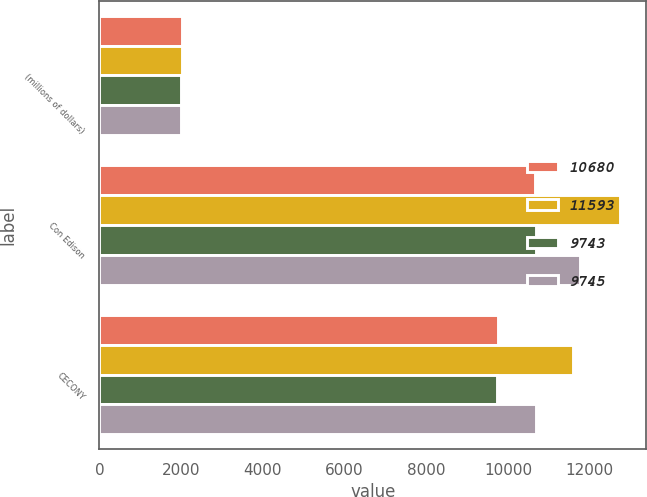Convert chart. <chart><loc_0><loc_0><loc_500><loc_500><stacked_bar_chart><ecel><fcel>(millions of dollars)<fcel>Con Edison<fcel>CECONY<nl><fcel>10680<fcel>2011<fcel>10673<fcel>9745<nl><fcel>11593<fcel>2011<fcel>12744<fcel>11593<nl><fcel>9743<fcel>2010<fcel>10676<fcel>9743<nl><fcel>9745<fcel>2010<fcel>11761<fcel>10680<nl></chart> 